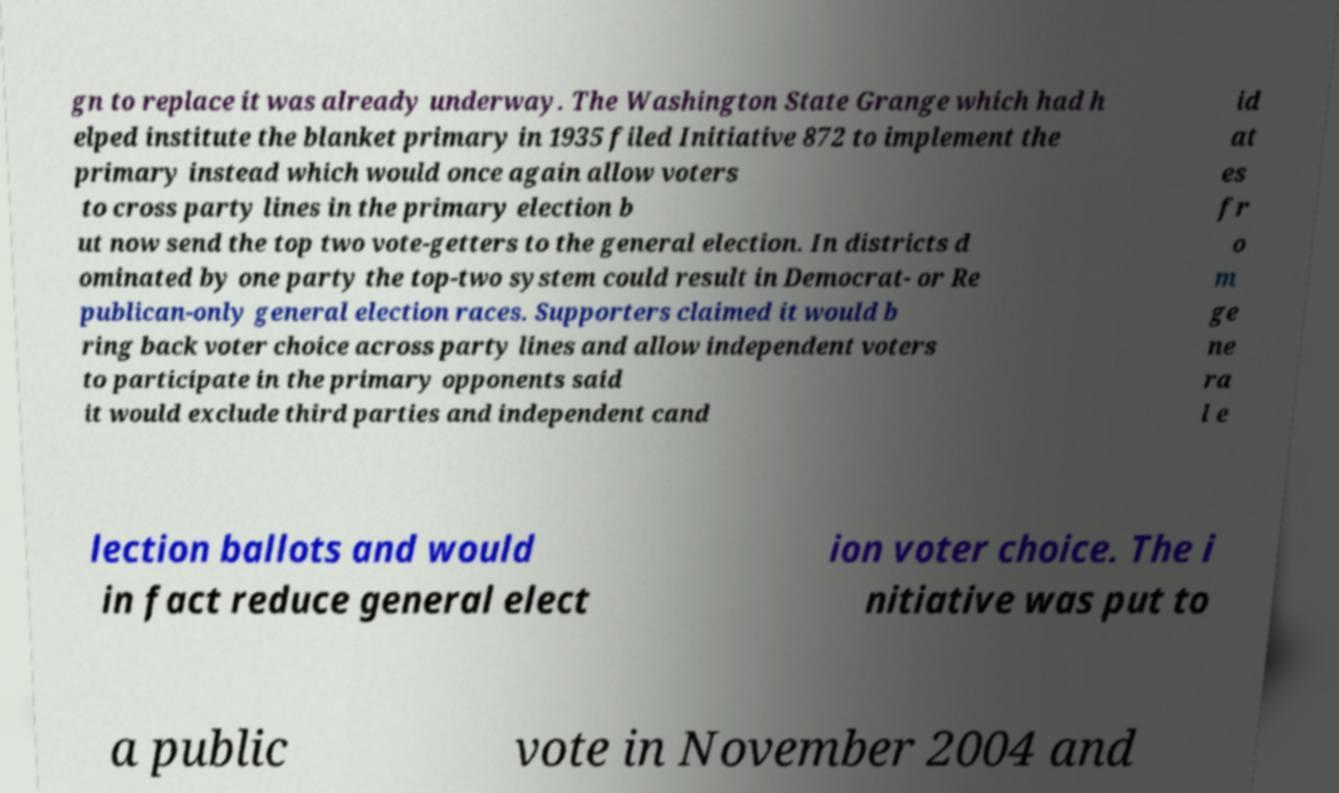Could you assist in decoding the text presented in this image and type it out clearly? gn to replace it was already underway. The Washington State Grange which had h elped institute the blanket primary in 1935 filed Initiative 872 to implement the primary instead which would once again allow voters to cross party lines in the primary election b ut now send the top two vote-getters to the general election. In districts d ominated by one party the top-two system could result in Democrat- or Re publican-only general election races. Supporters claimed it would b ring back voter choice across party lines and allow independent voters to participate in the primary opponents said it would exclude third parties and independent cand id at es fr o m ge ne ra l e lection ballots and would in fact reduce general elect ion voter choice. The i nitiative was put to a public vote in November 2004 and 